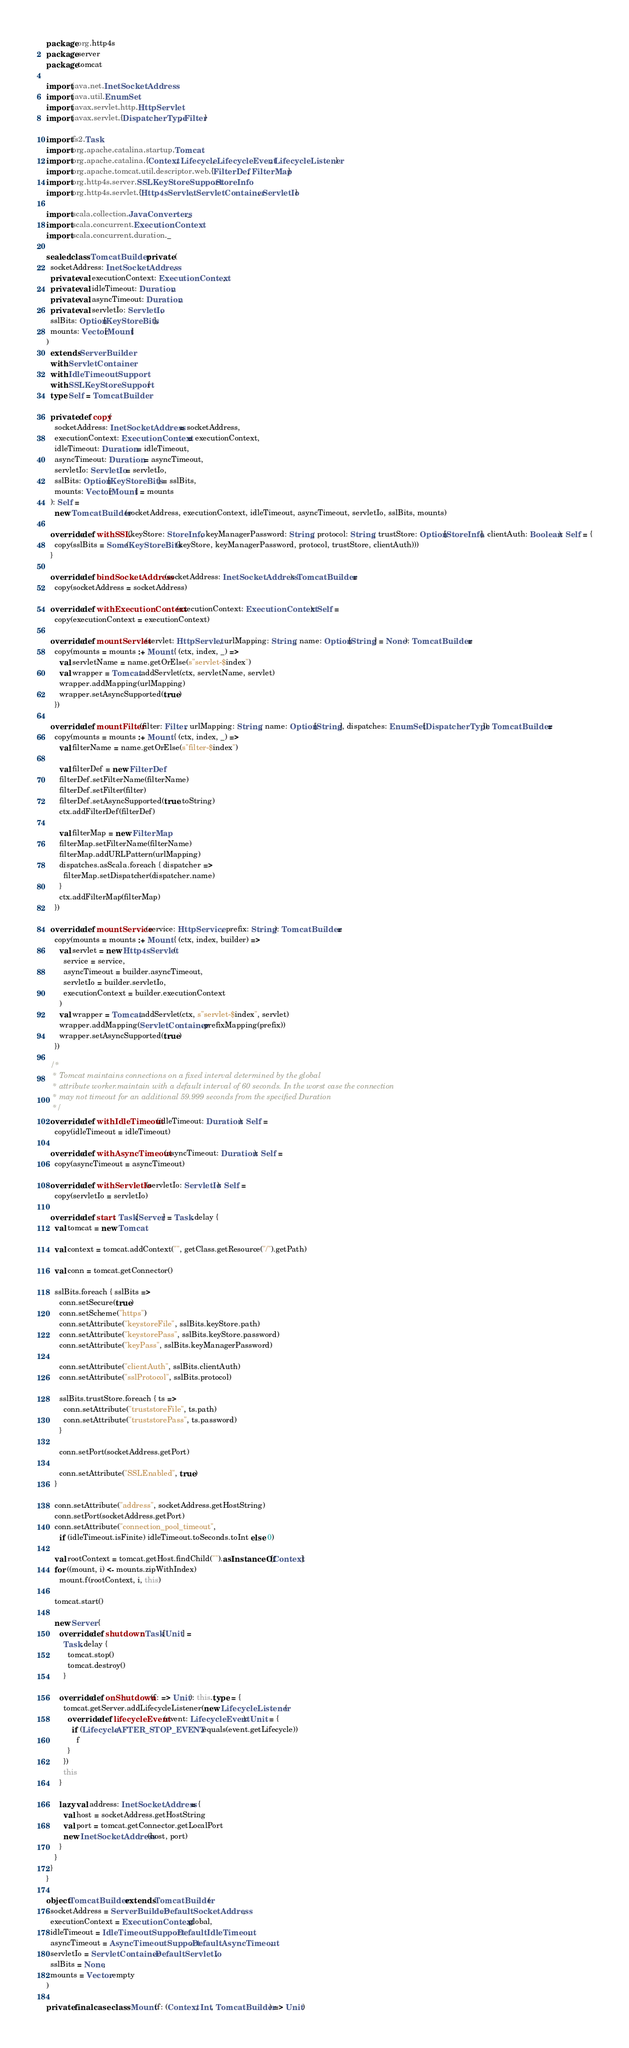<code> <loc_0><loc_0><loc_500><loc_500><_Scala_>package org.http4s
package server
package tomcat

import java.net.InetSocketAddress
import java.util.EnumSet
import javax.servlet.http.HttpServlet
import javax.servlet.{DispatcherType, Filter}

import fs2.Task
import org.apache.catalina.startup.Tomcat
import org.apache.catalina.{Context, Lifecycle, LifecycleEvent, LifecycleListener}
import org.apache.tomcat.util.descriptor.web.{FilterDef, FilterMap}
import org.http4s.server.SSLKeyStoreSupport.StoreInfo
import org.http4s.servlet.{Http4sServlet, ServletContainer, ServletIo}

import scala.collection.JavaConverters._
import scala.concurrent.ExecutionContext
import scala.concurrent.duration._

sealed class TomcatBuilder private (
  socketAddress: InetSocketAddress,
  private val executionContext: ExecutionContext,
  private val idleTimeout: Duration,
  private val asyncTimeout: Duration,
  private val servletIo: ServletIo,
  sslBits: Option[KeyStoreBits],
  mounts: Vector[Mount]
)
  extends ServerBuilder
  with ServletContainer
  with IdleTimeoutSupport
  with SSLKeyStoreSupport {
  type Self = TomcatBuilder

  private def copy(
    socketAddress: InetSocketAddress = socketAddress,
    executionContext: ExecutionContext = executionContext,
    idleTimeout: Duration = idleTimeout,
    asyncTimeout: Duration = asyncTimeout,
    servletIo: ServletIo = servletIo,
    sslBits: Option[KeyStoreBits] = sslBits,
    mounts: Vector[Mount] = mounts
  ): Self =
    new TomcatBuilder(socketAddress, executionContext, idleTimeout, asyncTimeout, servletIo, sslBits, mounts)

  override def withSSL(keyStore: StoreInfo, keyManagerPassword: String, protocol: String, trustStore: Option[StoreInfo], clientAuth: Boolean): Self = {
    copy(sslBits = Some(KeyStoreBits(keyStore, keyManagerPassword, protocol, trustStore, clientAuth)))
  }

  override def bindSocketAddress(socketAddress: InetSocketAddress): TomcatBuilder =
    copy(socketAddress = socketAddress)

  override def withExecutionContext(executionContext: ExecutionContext): Self =
    copy(executionContext = executionContext)

  override def mountServlet(servlet: HttpServlet, urlMapping: String, name: Option[String] = None): TomcatBuilder =
    copy(mounts = mounts :+ Mount { (ctx, index, _) =>
      val servletName = name.getOrElse(s"servlet-$index")
      val wrapper = Tomcat.addServlet(ctx, servletName, servlet)
      wrapper.addMapping(urlMapping)
      wrapper.setAsyncSupported(true)
    })

  override def mountFilter(filter: Filter, urlMapping: String, name: Option[String], dispatches: EnumSet[DispatcherType]): TomcatBuilder =
    copy(mounts = mounts :+ Mount { (ctx, index, _) =>
      val filterName = name.getOrElse(s"filter-$index")

      val filterDef = new FilterDef
      filterDef.setFilterName(filterName)
      filterDef.setFilter(filter)
      filterDef.setAsyncSupported(true.toString)
      ctx.addFilterDef(filterDef)

      val filterMap = new FilterMap
      filterMap.setFilterName(filterName)
      filterMap.addURLPattern(urlMapping)
      dispatches.asScala.foreach { dispatcher =>
        filterMap.setDispatcher(dispatcher.name)
      }
      ctx.addFilterMap(filterMap)
    })

  override def mountService(service: HttpService, prefix: String): TomcatBuilder =
    copy(mounts = mounts :+ Mount { (ctx, index, builder) =>
      val servlet = new Http4sServlet(
        service = service,
        asyncTimeout = builder.asyncTimeout,
        servletIo = builder.servletIo,
        executionContext = builder.executionContext
      )
      val wrapper = Tomcat.addServlet(ctx, s"servlet-$index", servlet)
      wrapper.addMapping(ServletContainer.prefixMapping(prefix))
      wrapper.setAsyncSupported(true)
    })

  /*
   * Tomcat maintains connections on a fixed interval determined by the global
   * attribute worker.maintain with a default interval of 60 seconds. In the worst case the connection
   * may not timeout for an additional 59.999 seconds from the specified Duration
   */
  override def withIdleTimeout(idleTimeout: Duration): Self =
    copy(idleTimeout = idleTimeout)

  override def withAsyncTimeout(asyncTimeout: Duration): Self =
    copy(asyncTimeout = asyncTimeout)

  override def withServletIo(servletIo: ServletIo): Self =
    copy(servletIo = servletIo)

  override def start: Task[Server] = Task.delay {
    val tomcat = new Tomcat

    val context = tomcat.addContext("", getClass.getResource("/").getPath)

    val conn = tomcat.getConnector()

    sslBits.foreach { sslBits =>
      conn.setSecure(true)
      conn.setScheme("https")
      conn.setAttribute("keystoreFile", sslBits.keyStore.path)
      conn.setAttribute("keystorePass", sslBits.keyStore.password)
      conn.setAttribute("keyPass", sslBits.keyManagerPassword)

      conn.setAttribute("clientAuth", sslBits.clientAuth)
      conn.setAttribute("sslProtocol", sslBits.protocol)

      sslBits.trustStore.foreach { ts =>
        conn.setAttribute("truststoreFile", ts.path)
        conn.setAttribute("truststorePass", ts.password)
      }

      conn.setPort(socketAddress.getPort)

      conn.setAttribute("SSLEnabled", true)
    }

    conn.setAttribute("address", socketAddress.getHostString)
    conn.setPort(socketAddress.getPort)
    conn.setAttribute("connection_pool_timeout",
      if (idleTimeout.isFinite) idleTimeout.toSeconds.toInt else 0)

    val rootContext = tomcat.getHost.findChild("").asInstanceOf[Context]
    for ((mount, i) <- mounts.zipWithIndex)
      mount.f(rootContext, i, this)

    tomcat.start()

    new Server {
      override def shutdown: Task[Unit] =
        Task.delay {
          tomcat.stop()
          tomcat.destroy()
        }

      override def onShutdown(f: => Unit): this.type = {
        tomcat.getServer.addLifecycleListener(new LifecycleListener {
          override def lifecycleEvent(event: LifecycleEvent): Unit = {
            if (Lifecycle.AFTER_STOP_EVENT.equals(event.getLifecycle))
              f
          }
        })
        this
      }

      lazy val address: InetSocketAddress = {
        val host = socketAddress.getHostString
        val port = tomcat.getConnector.getLocalPort
        new InetSocketAddress(host, port)
      }      
    }
  }
}

object TomcatBuilder extends TomcatBuilder(
  socketAddress = ServerBuilder.DefaultSocketAddress,
  executionContext = ExecutionContext.global,
  idleTimeout = IdleTimeoutSupport.DefaultIdleTimeout,
  asyncTimeout = AsyncTimeoutSupport.DefaultAsyncTimeout,
  servletIo = ServletContainer.DefaultServletIo,
  sslBits = None,
  mounts = Vector.empty
)

private final case class Mount(f: (Context, Int, TomcatBuilder) => Unit)

</code> 